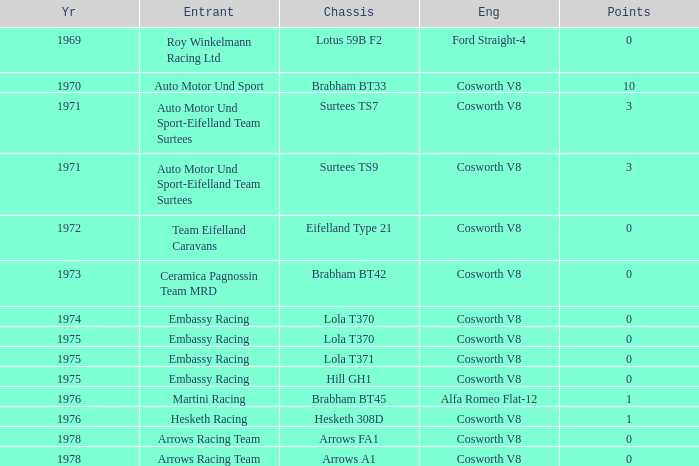In 1970, what entrant had a cosworth v8 engine? Auto Motor Und Sport. 